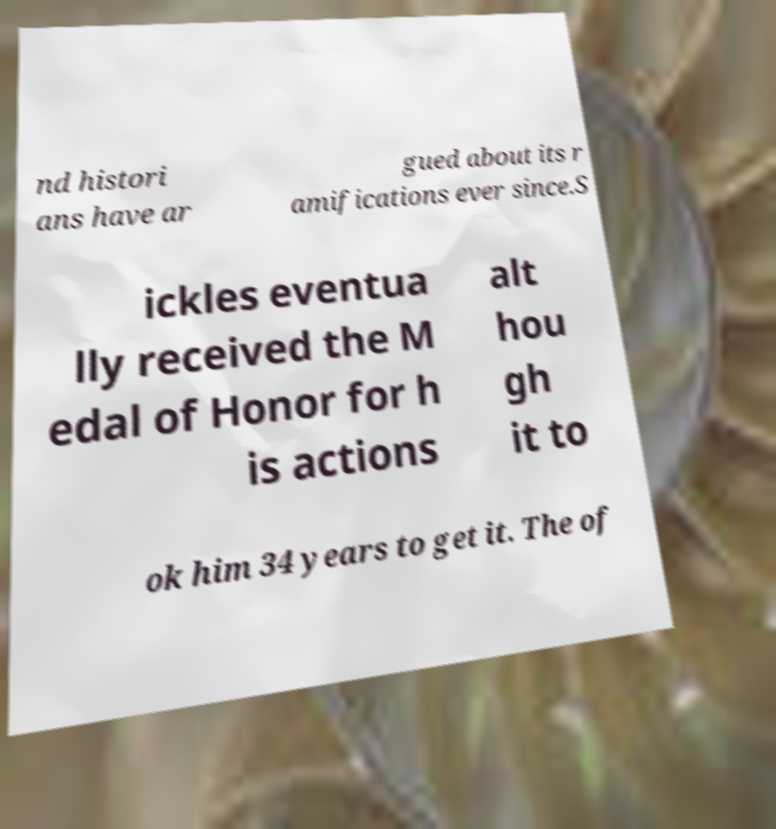Could you extract and type out the text from this image? nd histori ans have ar gued about its r amifications ever since.S ickles eventua lly received the M edal of Honor for h is actions alt hou gh it to ok him 34 years to get it. The of 